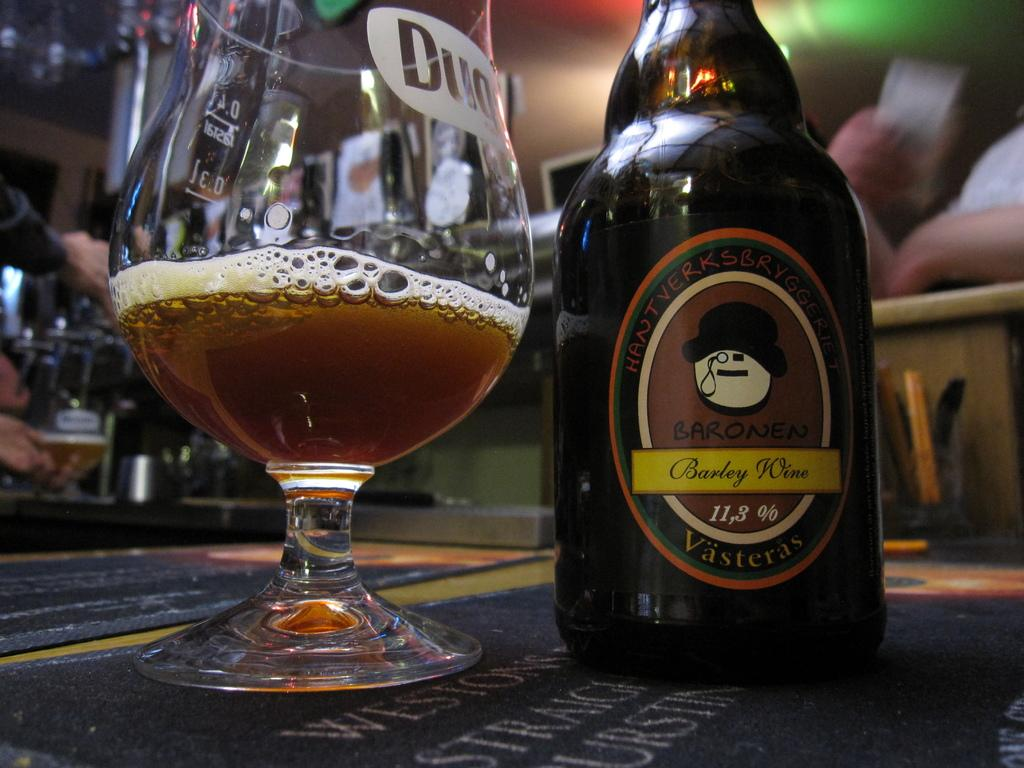Provide a one-sentence caption for the provided image. A half full glass sits next to a bottle of barley wine. 